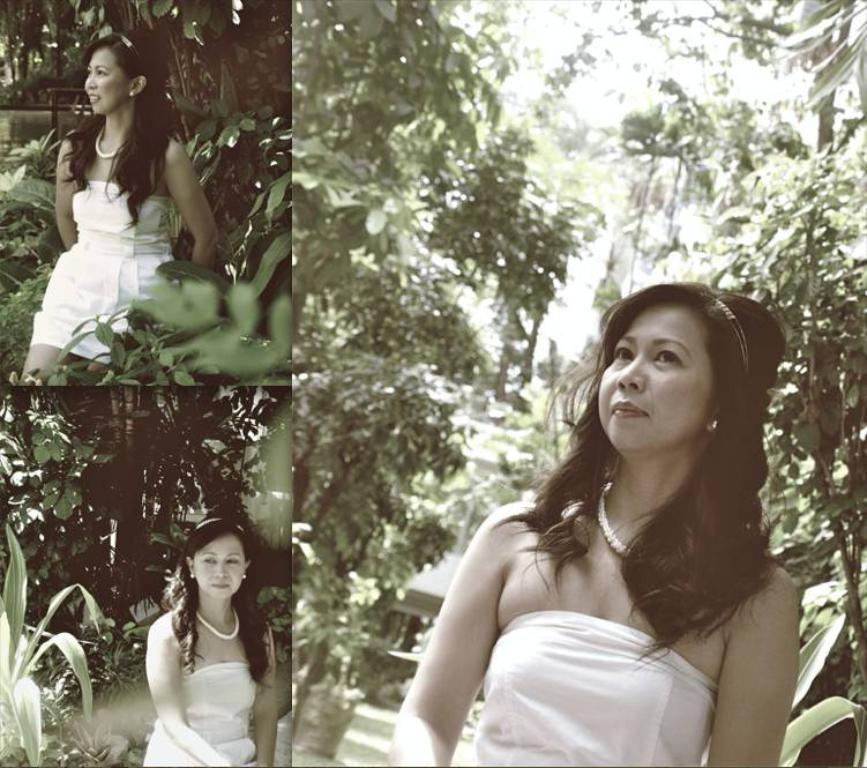What type of artwork is the image? The image is a collage. Can you describe the woman in the image? There is a woman in the image, and she is wearing a white dress. What is the woman's appearance like? The woman is stunning. What can be seen in the background of the image? There are trees and a building in the background of the image. What type of quill is the woman holding in the image? There is no quill present in the image. How much wealth is depicted in the image? The image does not depict any wealth or financial status. 